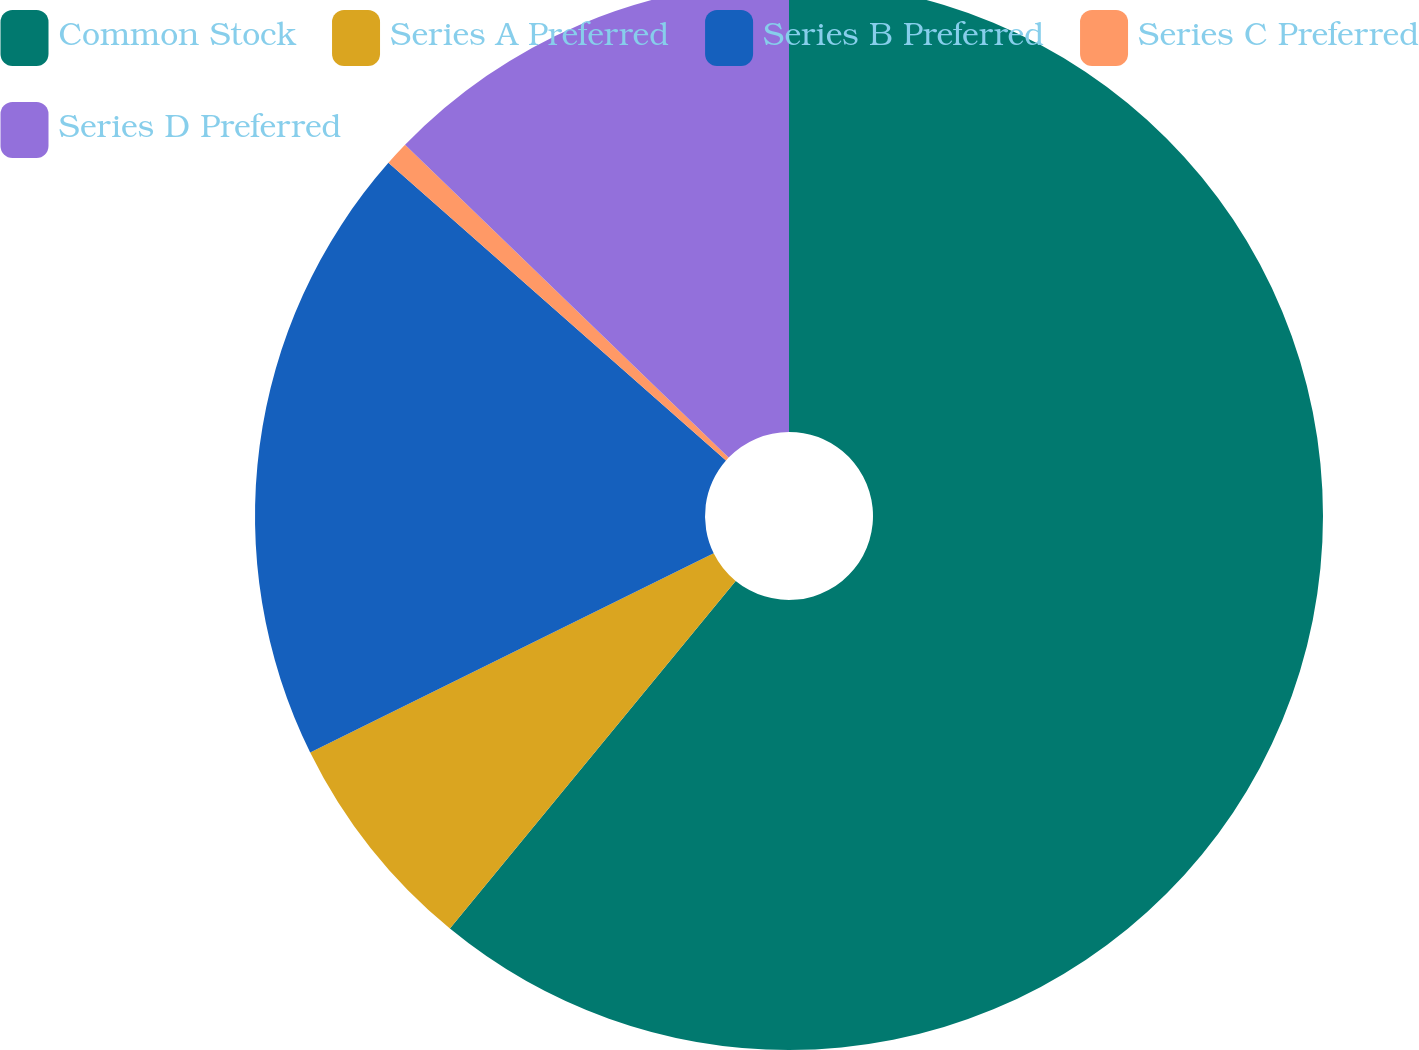<chart> <loc_0><loc_0><loc_500><loc_500><pie_chart><fcel>Common Stock<fcel>Series A Preferred<fcel>Series B Preferred<fcel>Series C Preferred<fcel>Series D Preferred<nl><fcel>60.95%<fcel>6.75%<fcel>18.8%<fcel>0.73%<fcel>12.77%<nl></chart> 